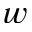<formula> <loc_0><loc_0><loc_500><loc_500>w</formula> 